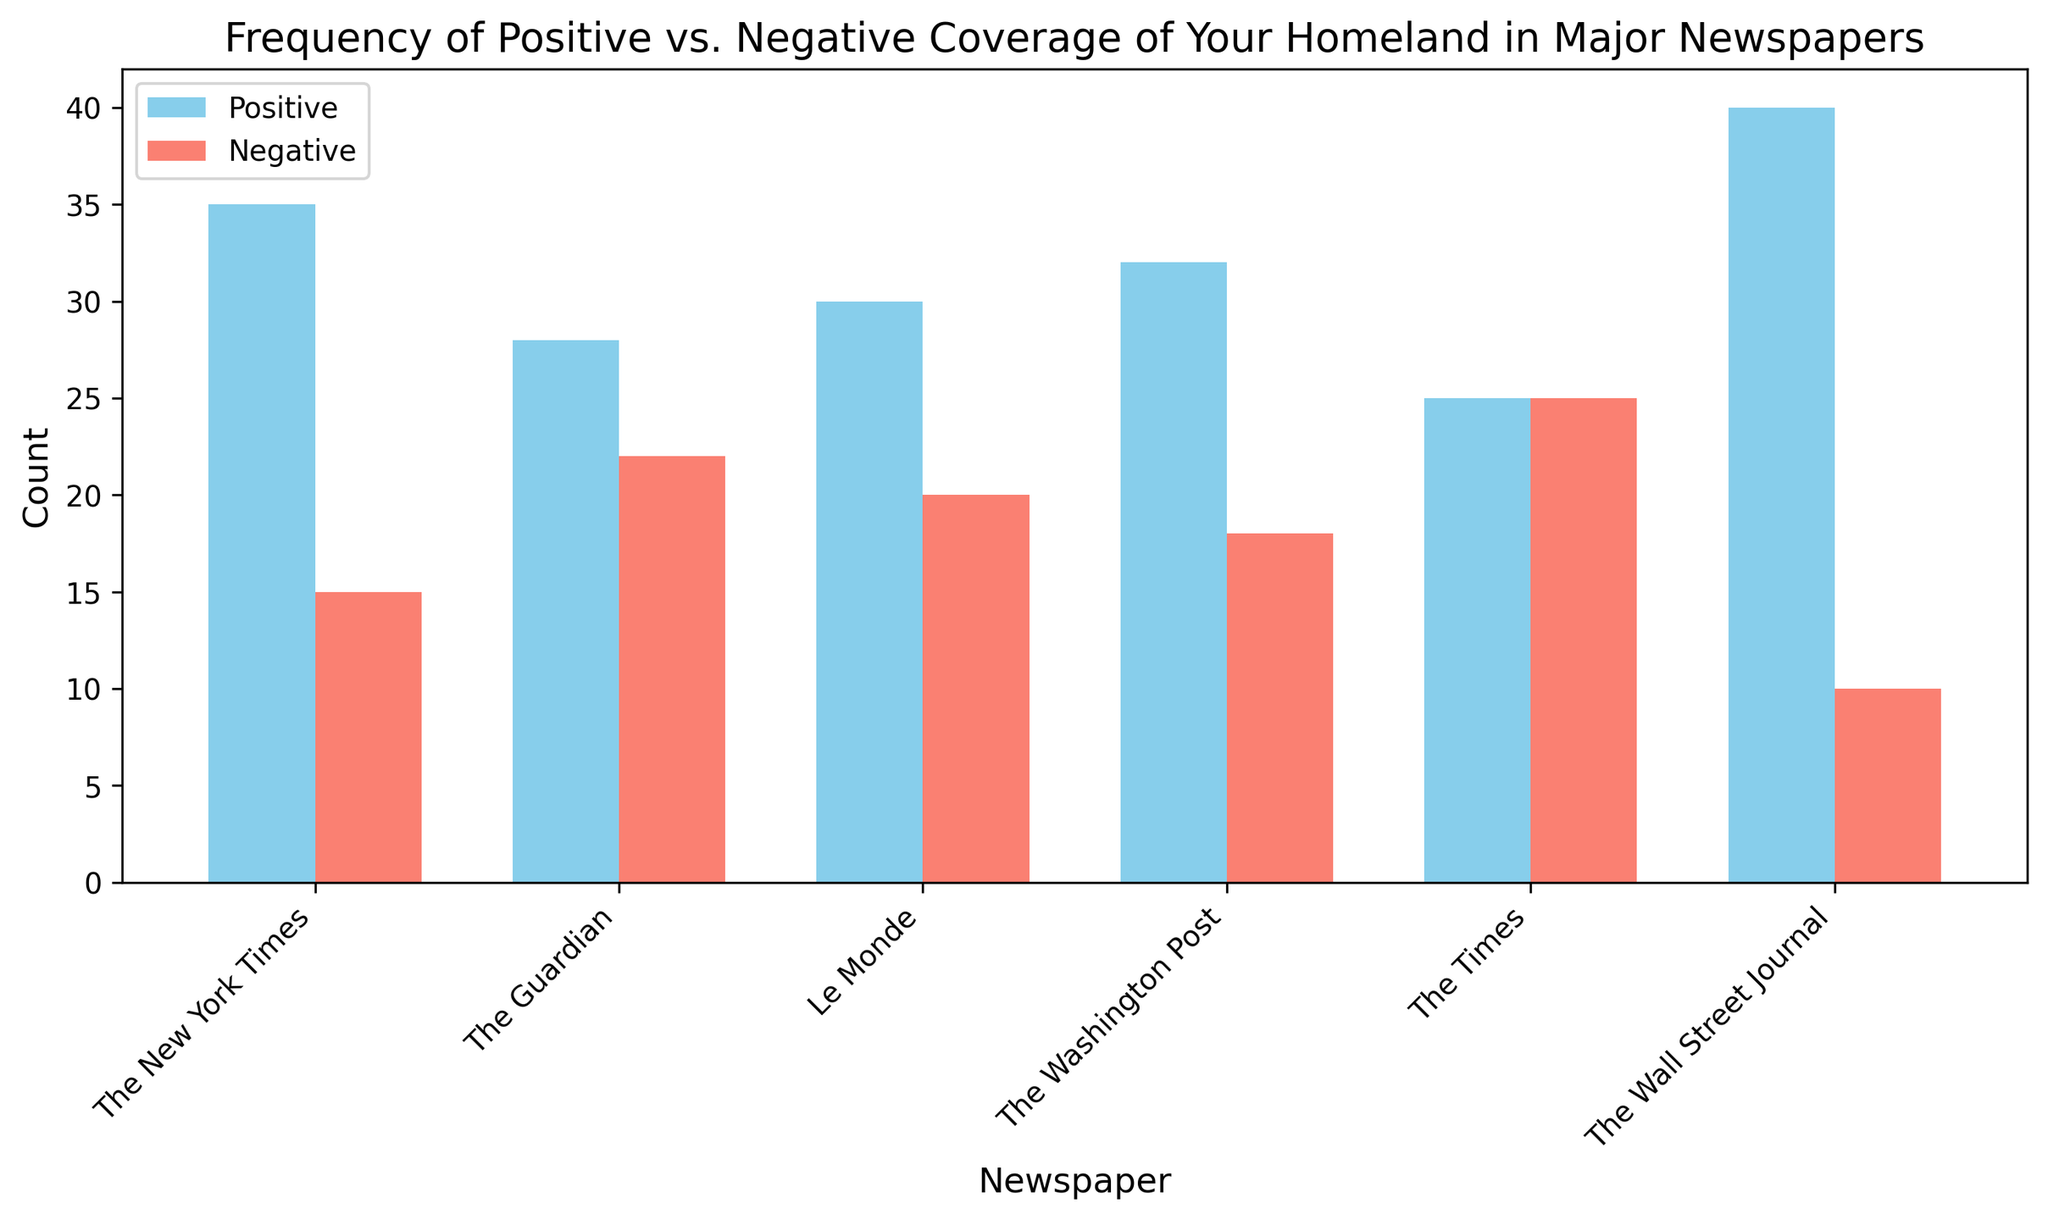Which newspaper has the highest amount of positive coverage of my homeland? The bar labeled "The Wall Street Journal" has the highest height among the positive coverage bars.
Answer: The Wall Street Journal Which newspaper has equal amounts of positive and negative coverage? The heights of the positive and negative bars for "The Times" appear to be the same.
Answer: The Times What is the total amount of positive coverage across all newspapers? Sum the individual positive counts: 35 (The New York Times) + 28 (The Guardian) + 30 (Le Monde) + 32 (The Washington Post) + 25 (The Times) + 40 (The Wall Street Journal) = 190.
Answer: 190 Which newspaper has the smallest difference between positive and negative coverage? Calculate the absolute difference for each newspaper: The Times (0), The Guardian (6), Le Monde (10), The Washington Post (14), The New York Times (20), The Wall Street Journal (30). The smallest difference is for "The Times."
Answer: The Times Which newspaper has fewer negative coverage instances than "Le Monde"? Newspapers with negative coverage bars shorter than Le Monde's (20) are "The Wall Street Journal" (10) and "The New York Times" (15).
Answer: The Wall Street Journal, The New York Times Which newspaper's positive coverage is closest to 30? Compare all positive bars: "Le Monde" (30) is exactly 30, while the others are different from 30.
Answer: Le Monde By how much does the positive coverage in "The Guardian" differ from those in "The Washington Post"? Calculate the difference: 32 (The Washington Post) - 28 (The Guardian) = 4.
Answer: 4 Which newspaper has the second highest negative coverage of my homeland? The second highest negative bar after "The Guardian" (22) is The New York Times (15).
Answer: The New York Times Across all newspapers, is the total positive coverage greater than the total negative coverage? Sum the positive counts (190) and the negative counts: 15 (The New York Times) + 22 (The Guardian) + 20 (Le Monde) + 18 (The Washington Post) + 25 (The Times) + 10 (The Wall Street Journal) = 110. Since 190 > 110, positive coverage totals are greater.
Answer: Yes 